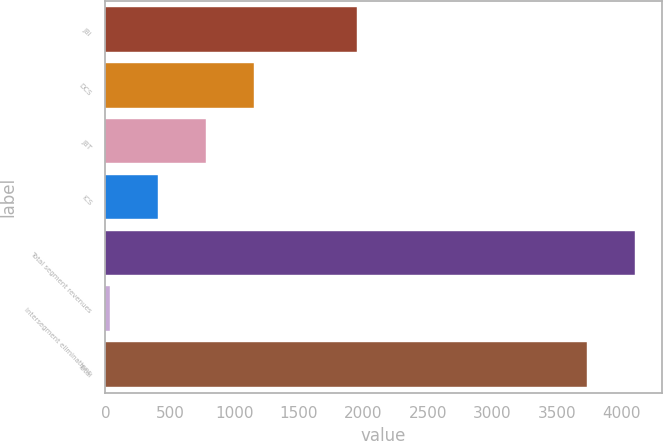<chart> <loc_0><loc_0><loc_500><loc_500><bar_chart><fcel>JBI<fcel>DCS<fcel>JBT<fcel>ICS<fcel>Total segment revenues<fcel>Intersegment eliminations<fcel>Total<nl><fcel>1952<fcel>1151.6<fcel>778.4<fcel>405.2<fcel>4105.2<fcel>32<fcel>3732<nl></chart> 